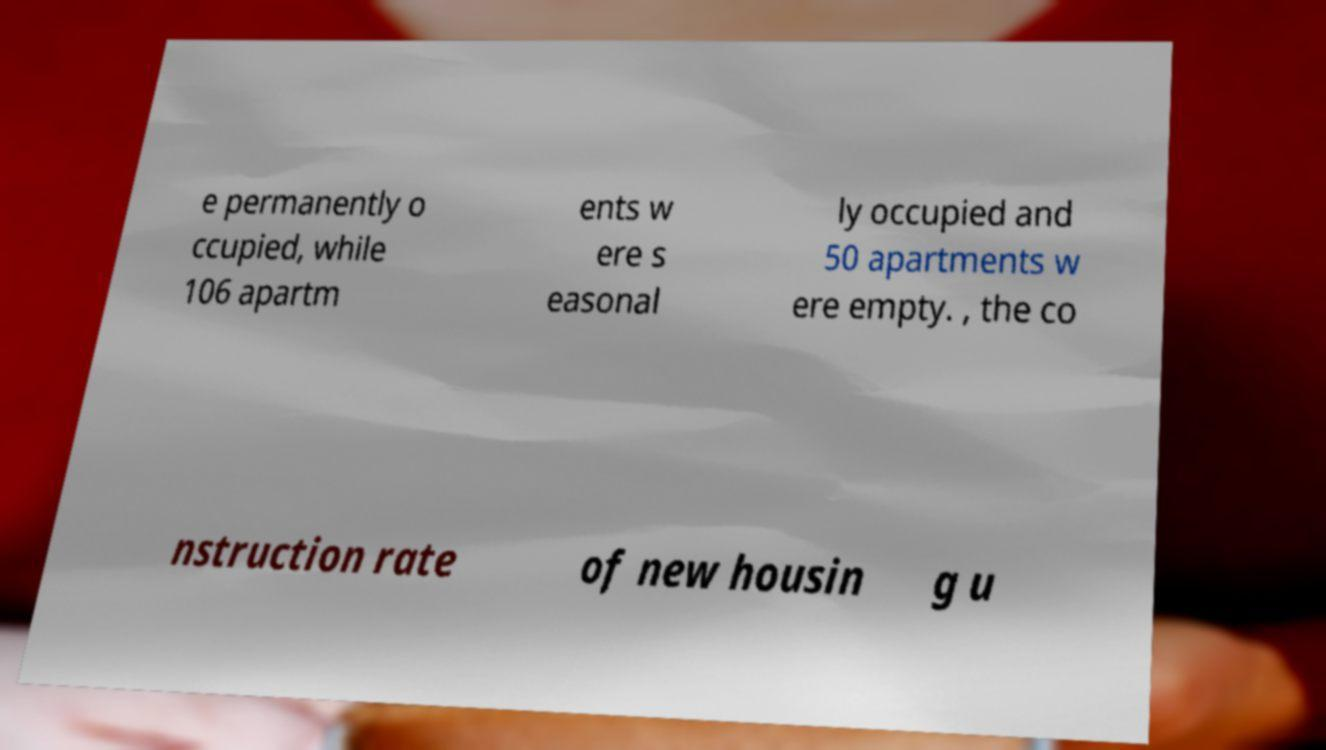Please read and relay the text visible in this image. What does it say? e permanently o ccupied, while 106 apartm ents w ere s easonal ly occupied and 50 apartments w ere empty. , the co nstruction rate of new housin g u 